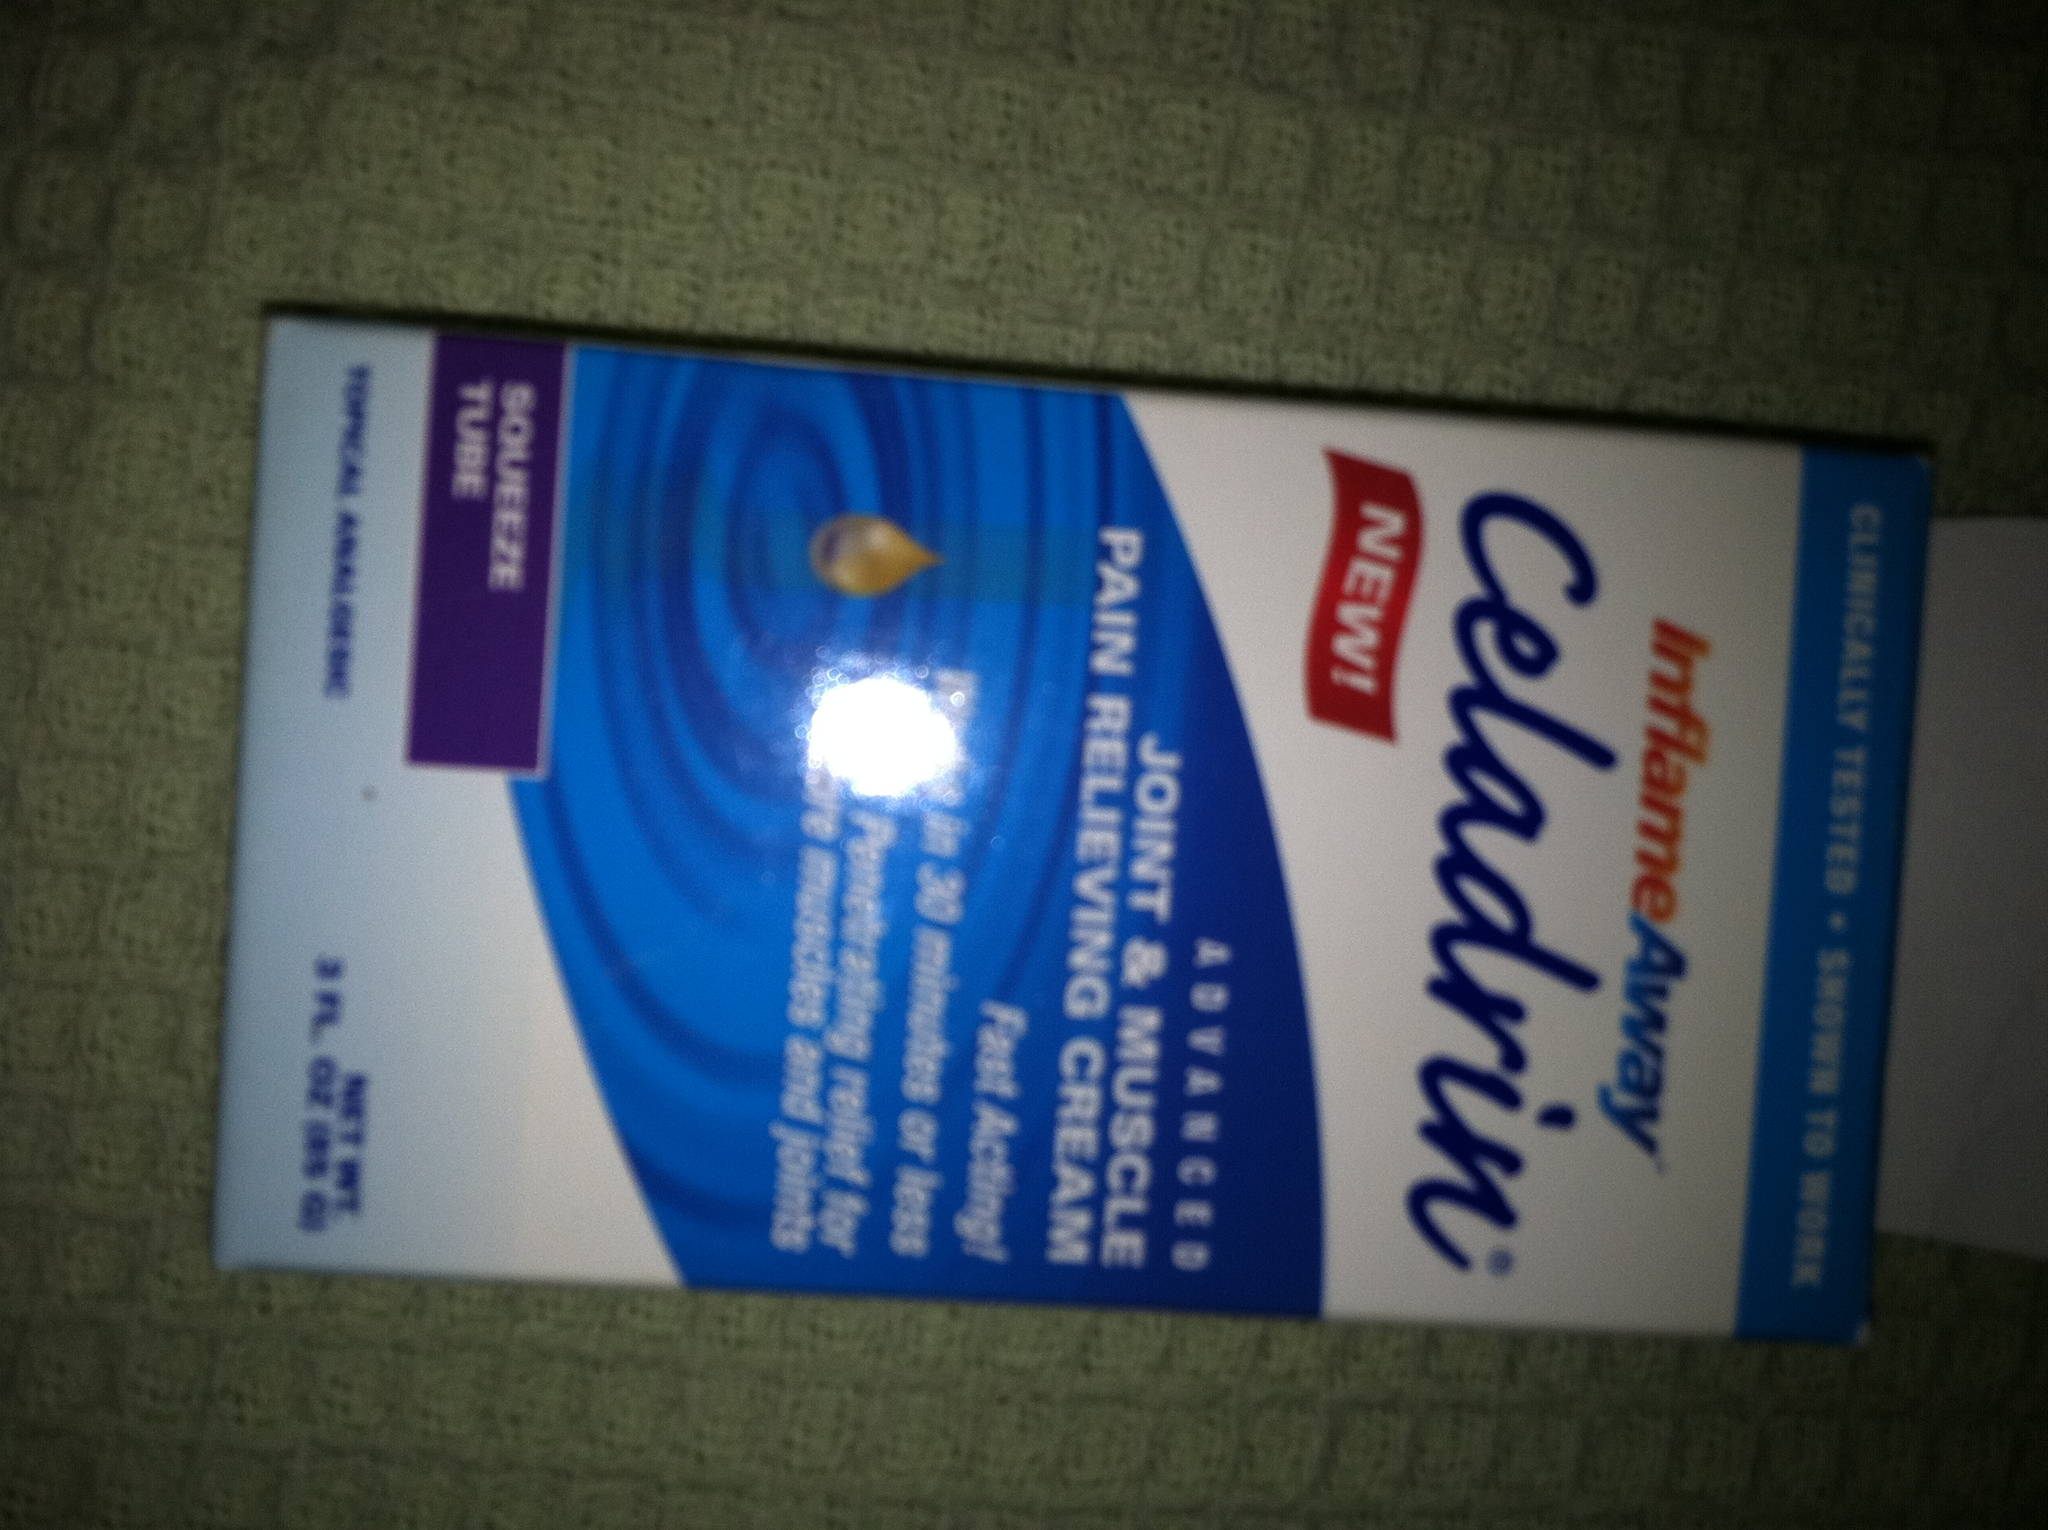Are there any precautions that need to be taken when using this cream? Yes, it's advisable to test a small amount on your skin first for any adverse reactions, as it contains capsaicin, which can cause a burning sensation. Avoid contact with eyes, wounds, or mucous membranes. If irritation develops, discontinue use immediately and consult a healthcare professional. 